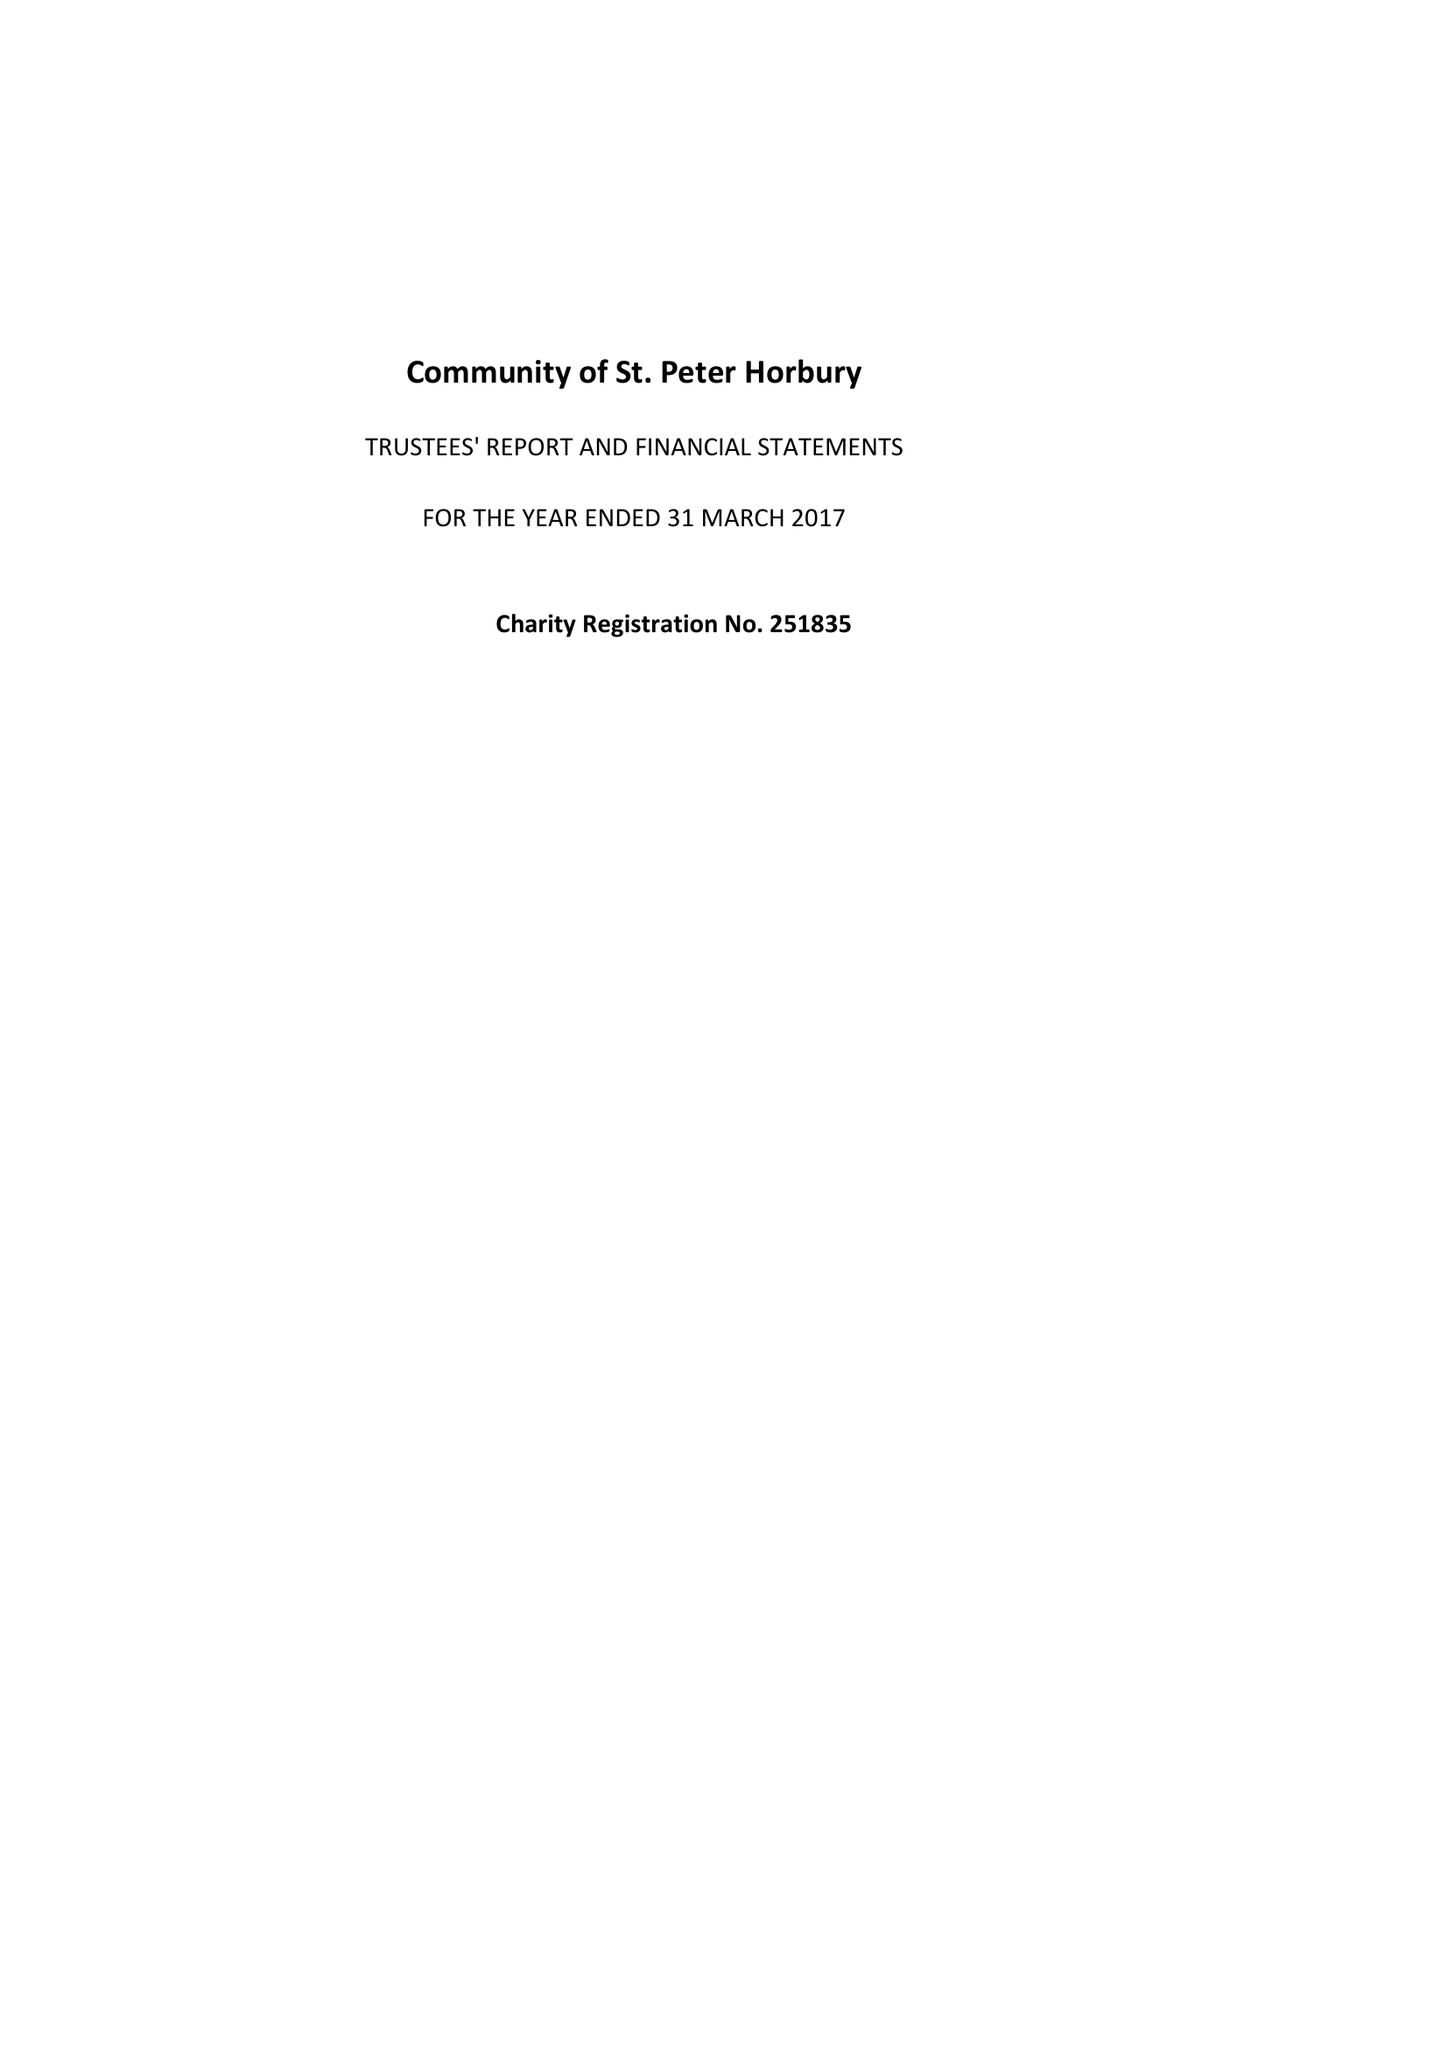What is the value for the income_annually_in_british_pounds?
Answer the question using a single word or phrase. 144671.00 